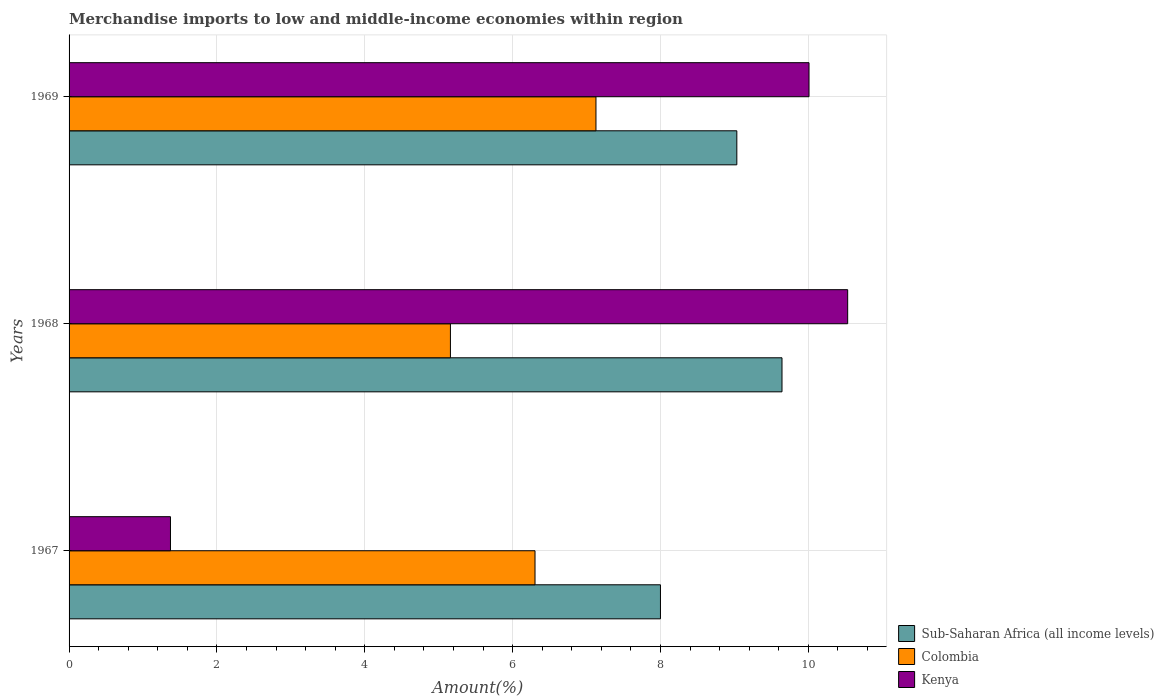How many different coloured bars are there?
Provide a short and direct response. 3. How many groups of bars are there?
Offer a terse response. 3. Are the number of bars on each tick of the Y-axis equal?
Provide a succinct answer. Yes. How many bars are there on the 3rd tick from the top?
Ensure brevity in your answer.  3. How many bars are there on the 1st tick from the bottom?
Make the answer very short. 3. What is the label of the 1st group of bars from the top?
Offer a terse response. 1969. What is the percentage of amount earned from merchandise imports in Colombia in 1968?
Your response must be concise. 5.16. Across all years, what is the maximum percentage of amount earned from merchandise imports in Colombia?
Keep it short and to the point. 7.13. Across all years, what is the minimum percentage of amount earned from merchandise imports in Colombia?
Keep it short and to the point. 5.16. In which year was the percentage of amount earned from merchandise imports in Kenya maximum?
Give a very brief answer. 1968. In which year was the percentage of amount earned from merchandise imports in Sub-Saharan Africa (all income levels) minimum?
Give a very brief answer. 1967. What is the total percentage of amount earned from merchandise imports in Sub-Saharan Africa (all income levels) in the graph?
Offer a very short reply. 26.68. What is the difference between the percentage of amount earned from merchandise imports in Colombia in 1967 and that in 1969?
Offer a very short reply. -0.82. What is the difference between the percentage of amount earned from merchandise imports in Kenya in 1967 and the percentage of amount earned from merchandise imports in Colombia in 1968?
Make the answer very short. -3.79. What is the average percentage of amount earned from merchandise imports in Kenya per year?
Give a very brief answer. 7.3. In the year 1968, what is the difference between the percentage of amount earned from merchandise imports in Colombia and percentage of amount earned from merchandise imports in Sub-Saharan Africa (all income levels)?
Make the answer very short. -4.49. In how many years, is the percentage of amount earned from merchandise imports in Colombia greater than 6.8 %?
Make the answer very short. 1. What is the ratio of the percentage of amount earned from merchandise imports in Sub-Saharan Africa (all income levels) in 1968 to that in 1969?
Ensure brevity in your answer.  1.07. Is the percentage of amount earned from merchandise imports in Colombia in 1967 less than that in 1968?
Provide a succinct answer. No. What is the difference between the highest and the second highest percentage of amount earned from merchandise imports in Kenya?
Ensure brevity in your answer.  0.52. What is the difference between the highest and the lowest percentage of amount earned from merchandise imports in Colombia?
Offer a very short reply. 1.97. What does the 1st bar from the top in 1969 represents?
Make the answer very short. Kenya. What does the 3rd bar from the bottom in 1969 represents?
Provide a succinct answer. Kenya. Is it the case that in every year, the sum of the percentage of amount earned from merchandise imports in Kenya and percentage of amount earned from merchandise imports in Sub-Saharan Africa (all income levels) is greater than the percentage of amount earned from merchandise imports in Colombia?
Make the answer very short. Yes. How many bars are there?
Your answer should be compact. 9. Are all the bars in the graph horizontal?
Your response must be concise. Yes. How many years are there in the graph?
Provide a short and direct response. 3. What is the title of the graph?
Offer a very short reply. Merchandise imports to low and middle-income economies within region. Does "Albania" appear as one of the legend labels in the graph?
Provide a short and direct response. No. What is the label or title of the X-axis?
Your response must be concise. Amount(%). What is the label or title of the Y-axis?
Ensure brevity in your answer.  Years. What is the Amount(%) in Sub-Saharan Africa (all income levels) in 1967?
Offer a terse response. 8. What is the Amount(%) in Colombia in 1967?
Offer a terse response. 6.3. What is the Amount(%) of Kenya in 1967?
Offer a terse response. 1.37. What is the Amount(%) in Sub-Saharan Africa (all income levels) in 1968?
Your answer should be compact. 9.64. What is the Amount(%) of Colombia in 1968?
Make the answer very short. 5.16. What is the Amount(%) in Kenya in 1968?
Make the answer very short. 10.53. What is the Amount(%) of Sub-Saharan Africa (all income levels) in 1969?
Your answer should be compact. 9.03. What is the Amount(%) of Colombia in 1969?
Your answer should be compact. 7.13. What is the Amount(%) of Kenya in 1969?
Provide a short and direct response. 10.01. Across all years, what is the maximum Amount(%) in Sub-Saharan Africa (all income levels)?
Offer a very short reply. 9.64. Across all years, what is the maximum Amount(%) of Colombia?
Make the answer very short. 7.13. Across all years, what is the maximum Amount(%) in Kenya?
Your answer should be very brief. 10.53. Across all years, what is the minimum Amount(%) in Sub-Saharan Africa (all income levels)?
Provide a short and direct response. 8. Across all years, what is the minimum Amount(%) of Colombia?
Offer a terse response. 5.16. Across all years, what is the minimum Amount(%) in Kenya?
Provide a short and direct response. 1.37. What is the total Amount(%) of Sub-Saharan Africa (all income levels) in the graph?
Provide a succinct answer. 26.68. What is the total Amount(%) in Colombia in the graph?
Give a very brief answer. 18.59. What is the total Amount(%) in Kenya in the graph?
Your answer should be very brief. 21.91. What is the difference between the Amount(%) in Sub-Saharan Africa (all income levels) in 1967 and that in 1968?
Make the answer very short. -1.64. What is the difference between the Amount(%) in Colombia in 1967 and that in 1968?
Keep it short and to the point. 1.14. What is the difference between the Amount(%) of Kenya in 1967 and that in 1968?
Offer a very short reply. -9.16. What is the difference between the Amount(%) in Sub-Saharan Africa (all income levels) in 1967 and that in 1969?
Your answer should be compact. -1.03. What is the difference between the Amount(%) in Colombia in 1967 and that in 1969?
Offer a very short reply. -0.82. What is the difference between the Amount(%) in Kenya in 1967 and that in 1969?
Your response must be concise. -8.64. What is the difference between the Amount(%) in Sub-Saharan Africa (all income levels) in 1968 and that in 1969?
Ensure brevity in your answer.  0.61. What is the difference between the Amount(%) in Colombia in 1968 and that in 1969?
Ensure brevity in your answer.  -1.97. What is the difference between the Amount(%) of Kenya in 1968 and that in 1969?
Ensure brevity in your answer.  0.52. What is the difference between the Amount(%) in Sub-Saharan Africa (all income levels) in 1967 and the Amount(%) in Colombia in 1968?
Make the answer very short. 2.84. What is the difference between the Amount(%) of Sub-Saharan Africa (all income levels) in 1967 and the Amount(%) of Kenya in 1968?
Keep it short and to the point. -2.53. What is the difference between the Amount(%) in Colombia in 1967 and the Amount(%) in Kenya in 1968?
Keep it short and to the point. -4.23. What is the difference between the Amount(%) of Sub-Saharan Africa (all income levels) in 1967 and the Amount(%) of Colombia in 1969?
Provide a succinct answer. 0.87. What is the difference between the Amount(%) in Sub-Saharan Africa (all income levels) in 1967 and the Amount(%) in Kenya in 1969?
Give a very brief answer. -2.01. What is the difference between the Amount(%) in Colombia in 1967 and the Amount(%) in Kenya in 1969?
Keep it short and to the point. -3.71. What is the difference between the Amount(%) of Sub-Saharan Africa (all income levels) in 1968 and the Amount(%) of Colombia in 1969?
Make the answer very short. 2.52. What is the difference between the Amount(%) in Sub-Saharan Africa (all income levels) in 1968 and the Amount(%) in Kenya in 1969?
Provide a short and direct response. -0.37. What is the difference between the Amount(%) in Colombia in 1968 and the Amount(%) in Kenya in 1969?
Offer a terse response. -4.85. What is the average Amount(%) of Sub-Saharan Africa (all income levels) per year?
Provide a short and direct response. 8.89. What is the average Amount(%) in Colombia per year?
Your response must be concise. 6.2. What is the average Amount(%) in Kenya per year?
Ensure brevity in your answer.  7.3. In the year 1967, what is the difference between the Amount(%) of Sub-Saharan Africa (all income levels) and Amount(%) of Colombia?
Your answer should be compact. 1.7. In the year 1967, what is the difference between the Amount(%) in Sub-Saharan Africa (all income levels) and Amount(%) in Kenya?
Your answer should be compact. 6.63. In the year 1967, what is the difference between the Amount(%) of Colombia and Amount(%) of Kenya?
Your answer should be compact. 4.93. In the year 1968, what is the difference between the Amount(%) in Sub-Saharan Africa (all income levels) and Amount(%) in Colombia?
Provide a succinct answer. 4.49. In the year 1968, what is the difference between the Amount(%) in Sub-Saharan Africa (all income levels) and Amount(%) in Kenya?
Ensure brevity in your answer.  -0.89. In the year 1968, what is the difference between the Amount(%) in Colombia and Amount(%) in Kenya?
Offer a very short reply. -5.37. In the year 1969, what is the difference between the Amount(%) of Sub-Saharan Africa (all income levels) and Amount(%) of Colombia?
Provide a short and direct response. 1.91. In the year 1969, what is the difference between the Amount(%) in Sub-Saharan Africa (all income levels) and Amount(%) in Kenya?
Keep it short and to the point. -0.98. In the year 1969, what is the difference between the Amount(%) of Colombia and Amount(%) of Kenya?
Give a very brief answer. -2.88. What is the ratio of the Amount(%) in Sub-Saharan Africa (all income levels) in 1967 to that in 1968?
Your answer should be compact. 0.83. What is the ratio of the Amount(%) of Colombia in 1967 to that in 1968?
Make the answer very short. 1.22. What is the ratio of the Amount(%) in Kenya in 1967 to that in 1968?
Your answer should be compact. 0.13. What is the ratio of the Amount(%) in Sub-Saharan Africa (all income levels) in 1967 to that in 1969?
Provide a short and direct response. 0.89. What is the ratio of the Amount(%) of Colombia in 1967 to that in 1969?
Make the answer very short. 0.88. What is the ratio of the Amount(%) in Kenya in 1967 to that in 1969?
Provide a succinct answer. 0.14. What is the ratio of the Amount(%) in Sub-Saharan Africa (all income levels) in 1968 to that in 1969?
Ensure brevity in your answer.  1.07. What is the ratio of the Amount(%) of Colombia in 1968 to that in 1969?
Make the answer very short. 0.72. What is the ratio of the Amount(%) of Kenya in 1968 to that in 1969?
Keep it short and to the point. 1.05. What is the difference between the highest and the second highest Amount(%) of Sub-Saharan Africa (all income levels)?
Give a very brief answer. 0.61. What is the difference between the highest and the second highest Amount(%) of Colombia?
Your answer should be very brief. 0.82. What is the difference between the highest and the second highest Amount(%) in Kenya?
Ensure brevity in your answer.  0.52. What is the difference between the highest and the lowest Amount(%) of Sub-Saharan Africa (all income levels)?
Give a very brief answer. 1.64. What is the difference between the highest and the lowest Amount(%) in Colombia?
Provide a short and direct response. 1.97. What is the difference between the highest and the lowest Amount(%) in Kenya?
Ensure brevity in your answer.  9.16. 